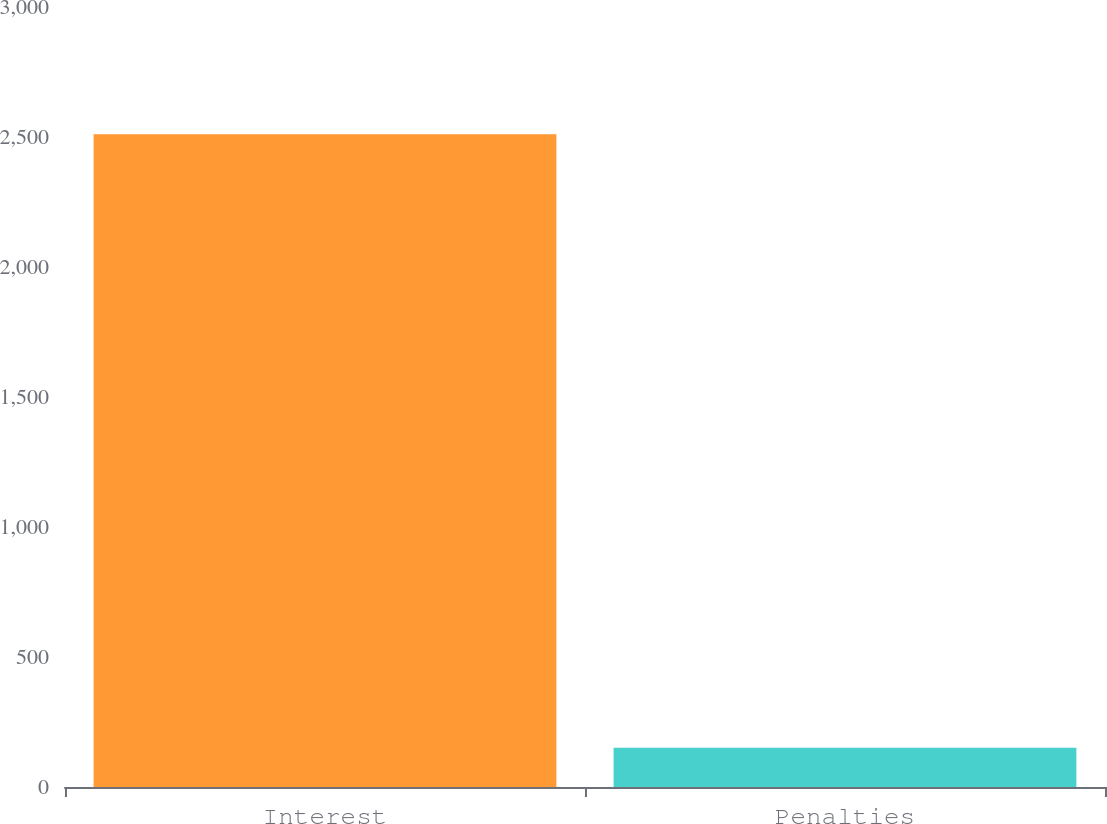<chart> <loc_0><loc_0><loc_500><loc_500><bar_chart><fcel>Interest<fcel>Penalties<nl><fcel>2511<fcel>151<nl></chart> 